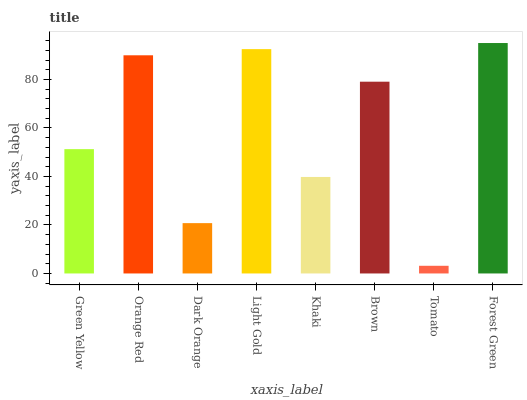Is Tomato the minimum?
Answer yes or no. Yes. Is Forest Green the maximum?
Answer yes or no. Yes. Is Orange Red the minimum?
Answer yes or no. No. Is Orange Red the maximum?
Answer yes or no. No. Is Orange Red greater than Green Yellow?
Answer yes or no. Yes. Is Green Yellow less than Orange Red?
Answer yes or no. Yes. Is Green Yellow greater than Orange Red?
Answer yes or no. No. Is Orange Red less than Green Yellow?
Answer yes or no. No. Is Brown the high median?
Answer yes or no. Yes. Is Green Yellow the low median?
Answer yes or no. Yes. Is Green Yellow the high median?
Answer yes or no. No. Is Brown the low median?
Answer yes or no. No. 